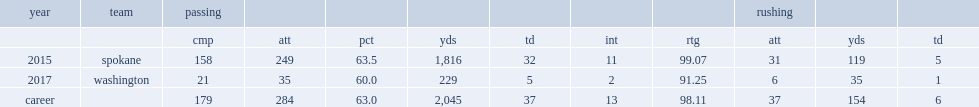How many passing yards did warren smith get in 2015? 1816.0. 